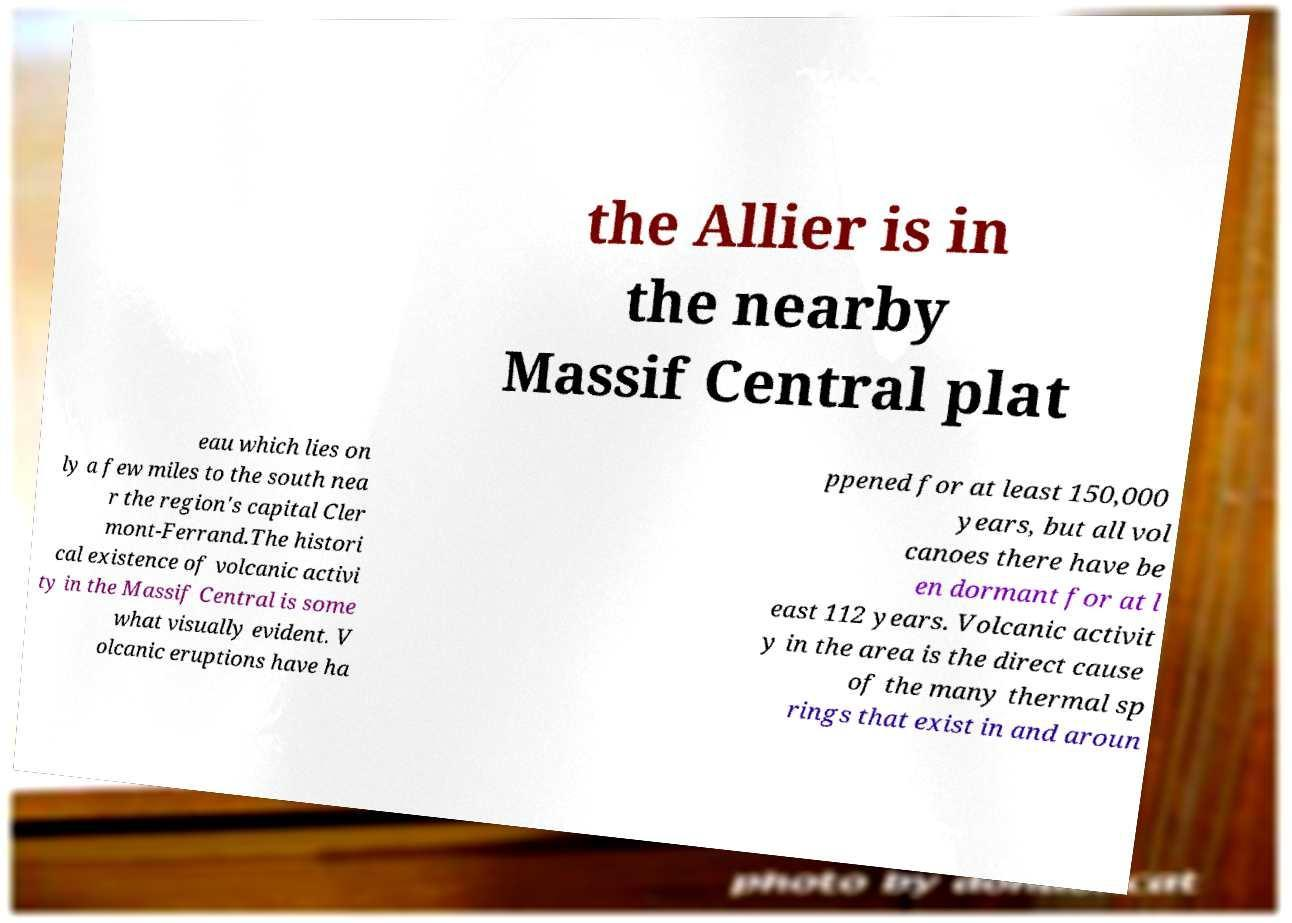Please read and relay the text visible in this image. What does it say? the Allier is in the nearby Massif Central plat eau which lies on ly a few miles to the south nea r the region's capital Cler mont-Ferrand.The histori cal existence of volcanic activi ty in the Massif Central is some what visually evident. V olcanic eruptions have ha ppened for at least 150,000 years, but all vol canoes there have be en dormant for at l east 112 years. Volcanic activit y in the area is the direct cause of the many thermal sp rings that exist in and aroun 